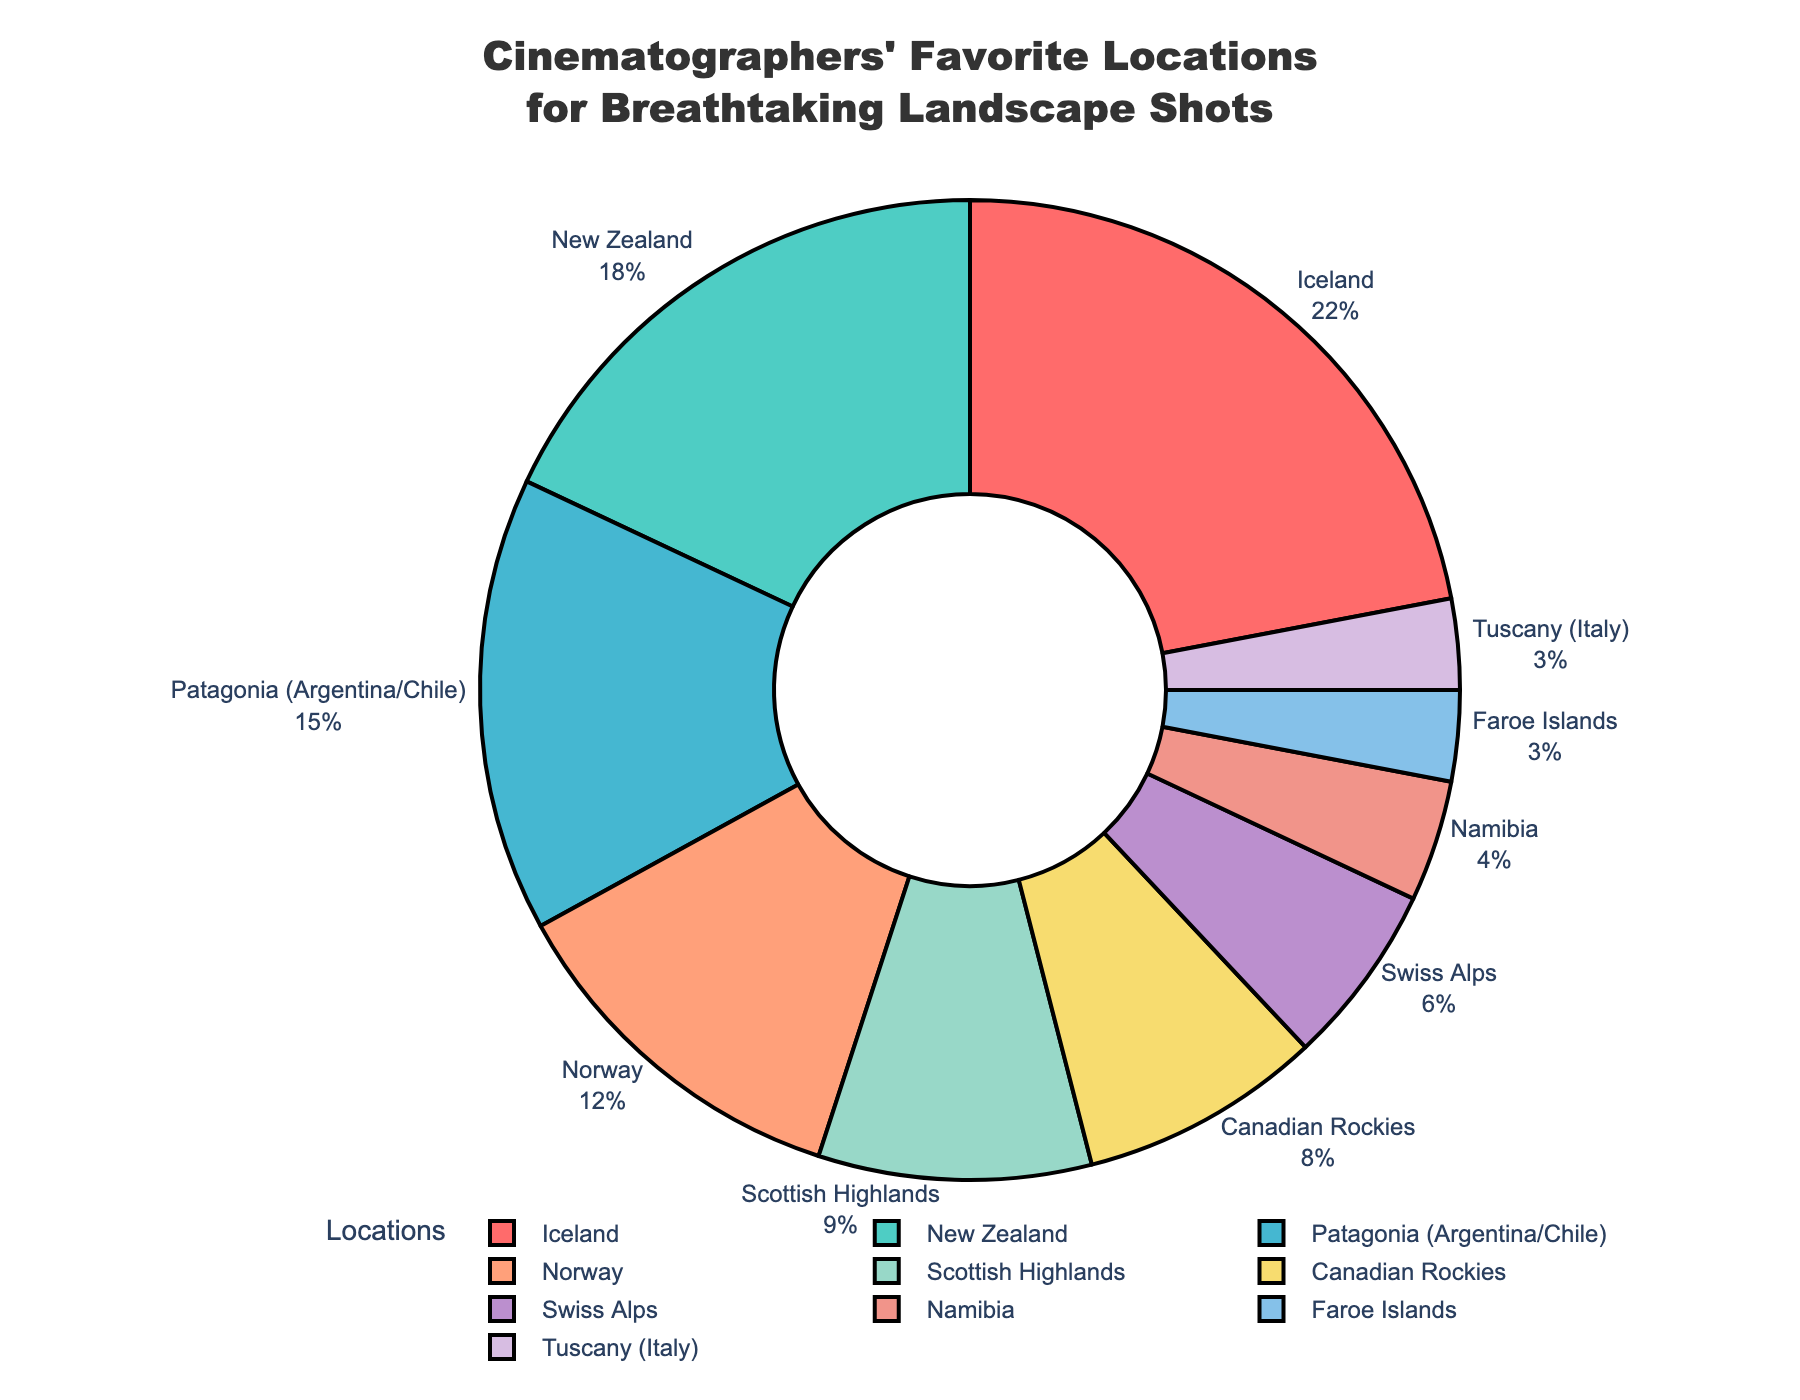What is the percentage of cinematographers' favorite location for capturing breathtaking shots in Iceland? The Iceland section of the pie chart shows a percentage.
Answer: 22% Which location has the least preference among cinematographers for capturing breathtaking shots? The Faroe Islands and Tuscany (Italy) have the lowest percentages in the pie chart, both are mentioned as having 3%.
Answer: Faroe Islands and Tuscany (Italy) By how much does the percentage of preference for Iceland exceed that for the Swiss Alps? The preference percentage for Iceland is 22% and for the Swiss Alps is 6%. Subtracting these, 22% - 6% = 16%.
Answer: 16% What is the combined percentage preference for Norway and the Scottish Highlands? The percentages for Norway and Scottish Highlands are 12% and 9%, respectively. Adding these, 12% + 9% = 21%.
Answer: 21% Which location has a higher preference, New Zealand or Patagonia (Argentina/Chile)? The pie chart shows that New Zealand has 18% and Patagonia (Argentina/Chile) has 15%. New Zealand is higher than Patagonia.
Answer: New Zealand What color represents the Canadian Rockies in the pie chart? Observing the pie chart's color labels, the section for the Canadian Rockies is marked with an orange color.
Answer: Orange Compare the percentage of preference between Namibia and the Faroe Islands. The pie chart shows Namibia with 4% and the Faroe Islands with 3%. Namibia has a higher percentage.
Answer: Namibia What is the total percentage of the top two favorite locations combined? The top two favorite locations are Iceland (22%) and New Zealand (18%). Combining these, 22% + 18% = 40%.
Answer: 40% What is the combined percentage preference for Canada (Canadian Rockies) and Switzerland (Swiss Alps)? The Canadian Rockies have 8% and the Swiss Alps have 6%. Adding these, 8% + 6% = 14%.
Answer: 14% Which locations have a combined preference percentage of less than 10%? The locations with under 10% are the Scottish Highlands (9%), Canadian Rockies (8%), Swiss Alps (6%), Namibia (4%), and Faroe Islands and Tuscany (Italy), both with 3%.
Answer: Scottish Highlands, Canadian Rockies, Swiss Alps, Namibia, Faroe Islands, Tuscany (Italy) 